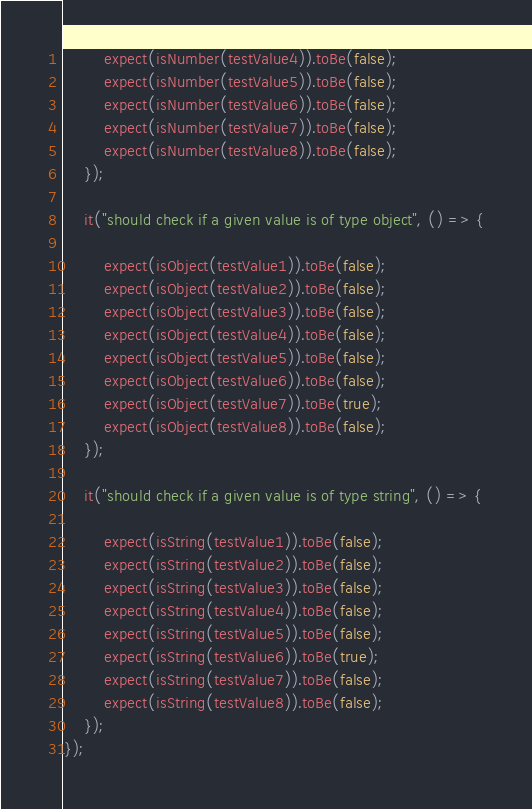<code> <loc_0><loc_0><loc_500><loc_500><_TypeScript_>        expect(isNumber(testValue4)).toBe(false);
        expect(isNumber(testValue5)).toBe(false);
        expect(isNumber(testValue6)).toBe(false);
        expect(isNumber(testValue7)).toBe(false);
        expect(isNumber(testValue8)).toBe(false);
    });

    it("should check if a given value is of type object", () => {

        expect(isObject(testValue1)).toBe(false);
        expect(isObject(testValue2)).toBe(false);
        expect(isObject(testValue3)).toBe(false);
        expect(isObject(testValue4)).toBe(false);
        expect(isObject(testValue5)).toBe(false);
        expect(isObject(testValue6)).toBe(false);
        expect(isObject(testValue7)).toBe(true);
        expect(isObject(testValue8)).toBe(false);
    });

    it("should check if a given value is of type string", () => {

        expect(isString(testValue1)).toBe(false);
        expect(isString(testValue2)).toBe(false);
        expect(isString(testValue3)).toBe(false);
        expect(isString(testValue4)).toBe(false);
        expect(isString(testValue5)).toBe(false);
        expect(isString(testValue6)).toBe(true);
        expect(isString(testValue7)).toBe(false);
        expect(isString(testValue8)).toBe(false);
    });
});</code> 